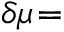Convert formula to latex. <formula><loc_0><loc_0><loc_500><loc_500>\delta \mu \, =</formula> 